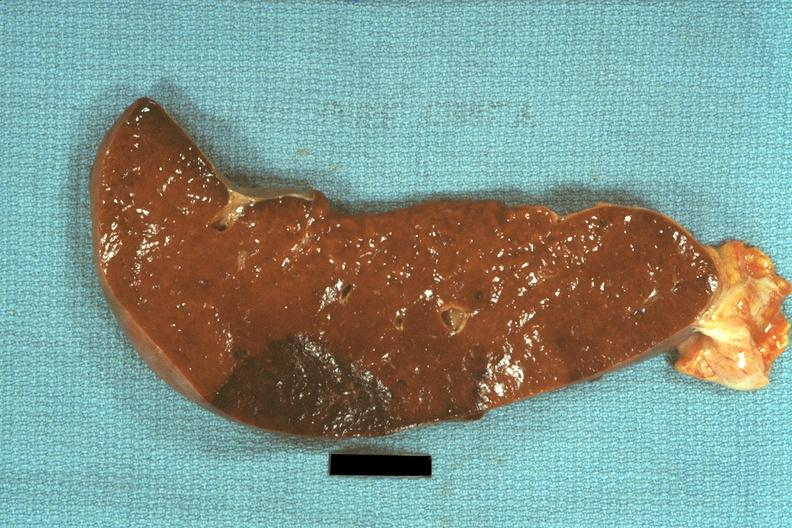s spleen present?
Answer the question using a single word or phrase. Yes 